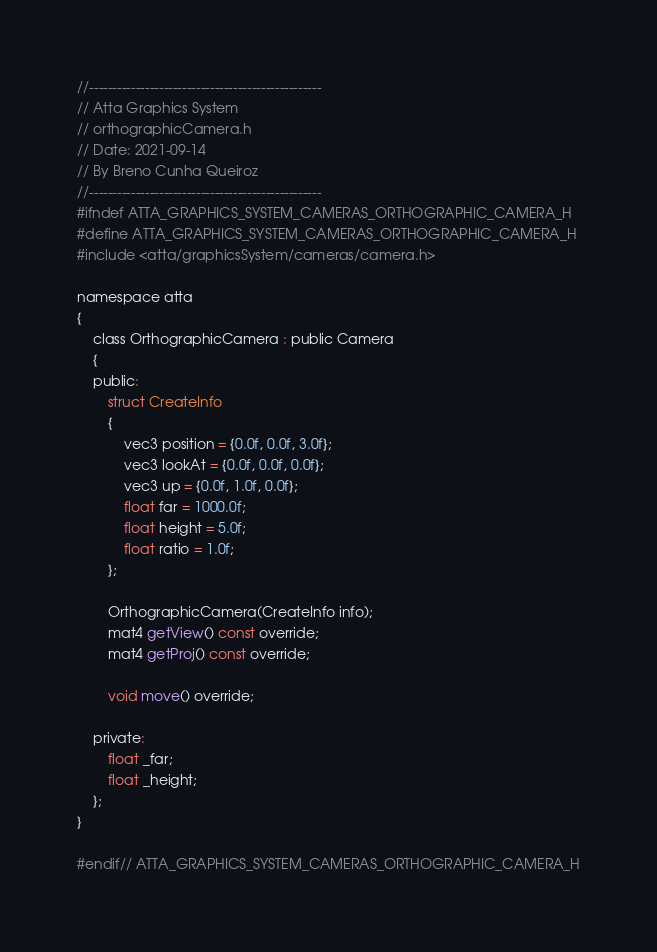<code> <loc_0><loc_0><loc_500><loc_500><_C_>//--------------------------------------------------
// Atta Graphics System
// orthographicCamera.h
// Date: 2021-09-14
// By Breno Cunha Queiroz
//--------------------------------------------------
#ifndef ATTA_GRAPHICS_SYSTEM_CAMERAS_ORTHOGRAPHIC_CAMERA_H
#define ATTA_GRAPHICS_SYSTEM_CAMERAS_ORTHOGRAPHIC_CAMERA_H
#include <atta/graphicsSystem/cameras/camera.h>

namespace atta
{
    class OrthographicCamera : public Camera
    {
    public:
        struct CreateInfo
        {
            vec3 position = {0.0f, 0.0f, 3.0f};
            vec3 lookAt = {0.0f, 0.0f, 0.0f};
            vec3 up = {0.0f, 1.0f, 0.0f};
            float far = 1000.0f;
            float height = 5.0f;
            float ratio = 1.0f;
        };

        OrthographicCamera(CreateInfo info);
        mat4 getView() const override;
        mat4 getProj() const override;

        void move() override;

    private:
        float _far;
        float _height;
    };
}

#endif// ATTA_GRAPHICS_SYSTEM_CAMERAS_ORTHOGRAPHIC_CAMERA_H
</code> 